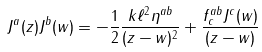<formula> <loc_0><loc_0><loc_500><loc_500>J ^ { a } ( z ) J ^ { b } ( w ) = - \frac { 1 } { 2 } \frac { k \ell ^ { 2 } \eta ^ { a b } } { ( z - w ) ^ { 2 } } + \frac { f _ { c } ^ { a b } J ^ { c } ( w ) } { ( z - w ) }</formula> 